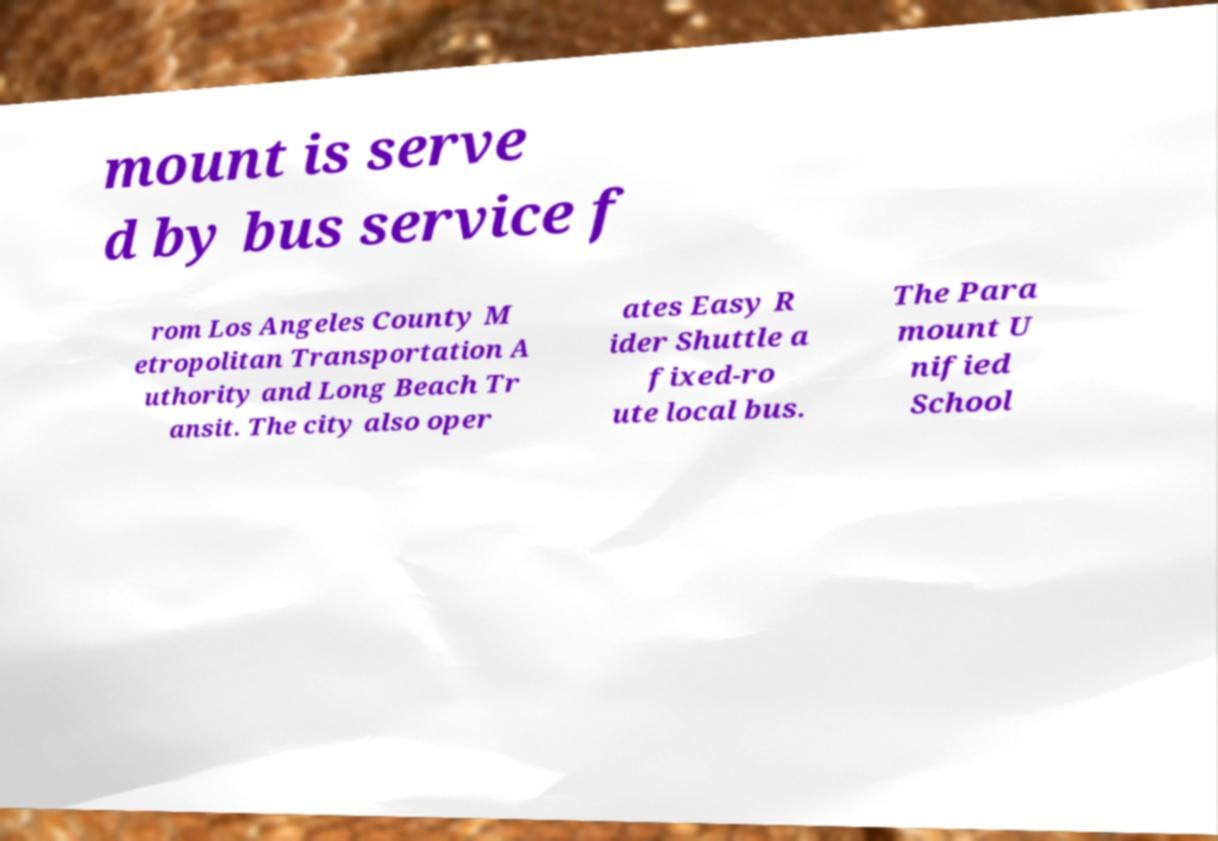For documentation purposes, I need the text within this image transcribed. Could you provide that? mount is serve d by bus service f rom Los Angeles County M etropolitan Transportation A uthority and Long Beach Tr ansit. The city also oper ates Easy R ider Shuttle a fixed-ro ute local bus. The Para mount U nified School 